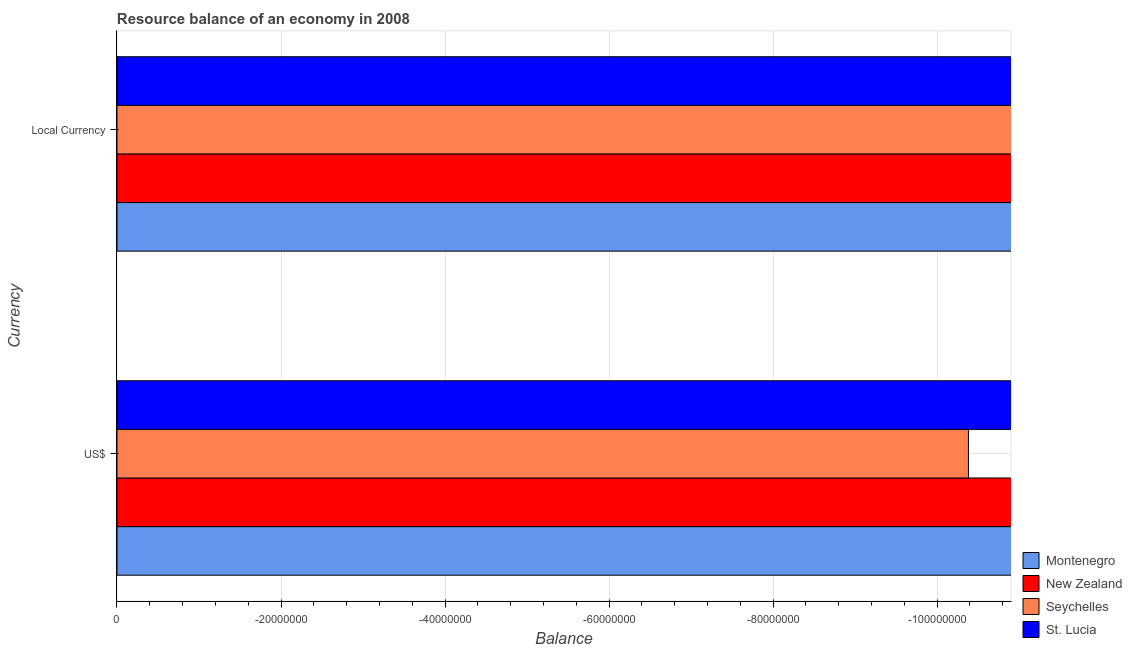How many different coloured bars are there?
Make the answer very short. 0. Are the number of bars per tick equal to the number of legend labels?
Offer a very short reply. No. Are the number of bars on each tick of the Y-axis equal?
Offer a very short reply. Yes. How many bars are there on the 2nd tick from the top?
Provide a short and direct response. 0. How many bars are there on the 1st tick from the bottom?
Offer a very short reply. 0. What is the label of the 2nd group of bars from the top?
Your response must be concise. US$. What is the resource balance in constant us$ in New Zealand?
Give a very brief answer. 0. Across all countries, what is the minimum resource balance in constant us$?
Make the answer very short. 0. What is the total resource balance in us$ in the graph?
Your response must be concise. 0. What is the average resource balance in constant us$ per country?
Ensure brevity in your answer.  0. In how many countries, is the resource balance in constant us$ greater than -28000000 units?
Provide a short and direct response. 0. How many bars are there?
Provide a short and direct response. 0. Are the values on the major ticks of X-axis written in scientific E-notation?
Make the answer very short. No. Does the graph contain grids?
Offer a terse response. Yes. Where does the legend appear in the graph?
Your answer should be very brief. Bottom right. How many legend labels are there?
Make the answer very short. 4. What is the title of the graph?
Provide a succinct answer. Resource balance of an economy in 2008. Does "Sao Tome and Principe" appear as one of the legend labels in the graph?
Ensure brevity in your answer.  No. What is the label or title of the X-axis?
Make the answer very short. Balance. What is the label or title of the Y-axis?
Your answer should be very brief. Currency. What is the Balance in New Zealand in US$?
Provide a succinct answer. 0. What is the Balance of Montenegro in Local Currency?
Ensure brevity in your answer.  0. What is the Balance in Seychelles in Local Currency?
Provide a succinct answer. 0. What is the Balance in St. Lucia in Local Currency?
Your answer should be very brief. 0. What is the total Balance in Montenegro in the graph?
Offer a terse response. 0. What is the total Balance of New Zealand in the graph?
Your answer should be very brief. 0. What is the total Balance in Seychelles in the graph?
Offer a very short reply. 0. What is the total Balance in St. Lucia in the graph?
Your response must be concise. 0. What is the average Balance in St. Lucia per Currency?
Your answer should be very brief. 0. 